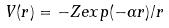Convert formula to latex. <formula><loc_0><loc_0><loc_500><loc_500>V ( r ) = - Z e x p ( - \alpha r ) / r</formula> 